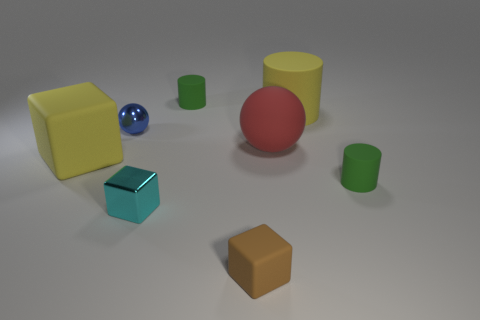There is a block that is the same color as the large cylinder; what is its size?
Your answer should be compact. Large. The small green thing right of the cylinder that is behind the yellow cylinder is what shape?
Your response must be concise. Cylinder. There is a yellow thing that is left of the tiny green cylinder that is to the left of the green rubber thing to the right of the brown rubber cube; what size is it?
Your answer should be compact. Large. There is another object that is the same shape as the blue metal thing; what is its color?
Your answer should be very brief. Red. Is the size of the cyan thing the same as the matte sphere?
Your answer should be compact. No. There is a tiny object that is on the left side of the small cyan object; what is it made of?
Your answer should be compact. Metal. How many other objects are the same shape as the tiny cyan object?
Offer a terse response. 2. Do the small cyan object and the tiny brown thing have the same shape?
Your response must be concise. Yes. There is a large rubber cylinder; are there any green rubber cylinders on the left side of it?
Provide a succinct answer. Yes. What number of things are either red metallic objects or small objects?
Offer a very short reply. 5. 